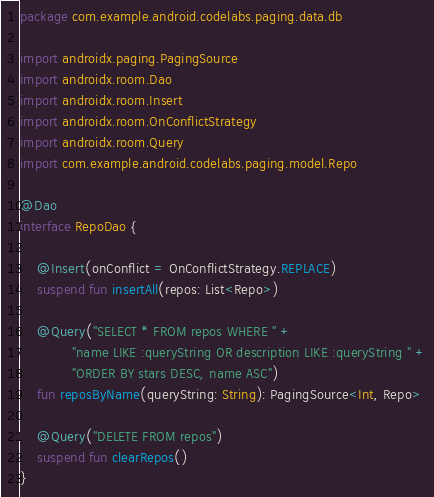Convert code to text. <code><loc_0><loc_0><loc_500><loc_500><_Kotlin_>package com.example.android.codelabs.paging.data.db

import androidx.paging.PagingSource
import androidx.room.Dao
import androidx.room.Insert
import androidx.room.OnConflictStrategy
import androidx.room.Query
import com.example.android.codelabs.paging.model.Repo

@Dao
interface RepoDao {

    @Insert(onConflict = OnConflictStrategy.REPLACE)
    suspend fun insertAll(repos: List<Repo>)

    @Query("SELECT * FROM repos WHERE " +
            "name LIKE :queryString OR description LIKE :queryString " +
            "ORDER BY stars DESC, name ASC")
    fun reposByName(queryString: String): PagingSource<Int, Repo>

    @Query("DELETE FROM repos")
    suspend fun clearRepos()
}</code> 